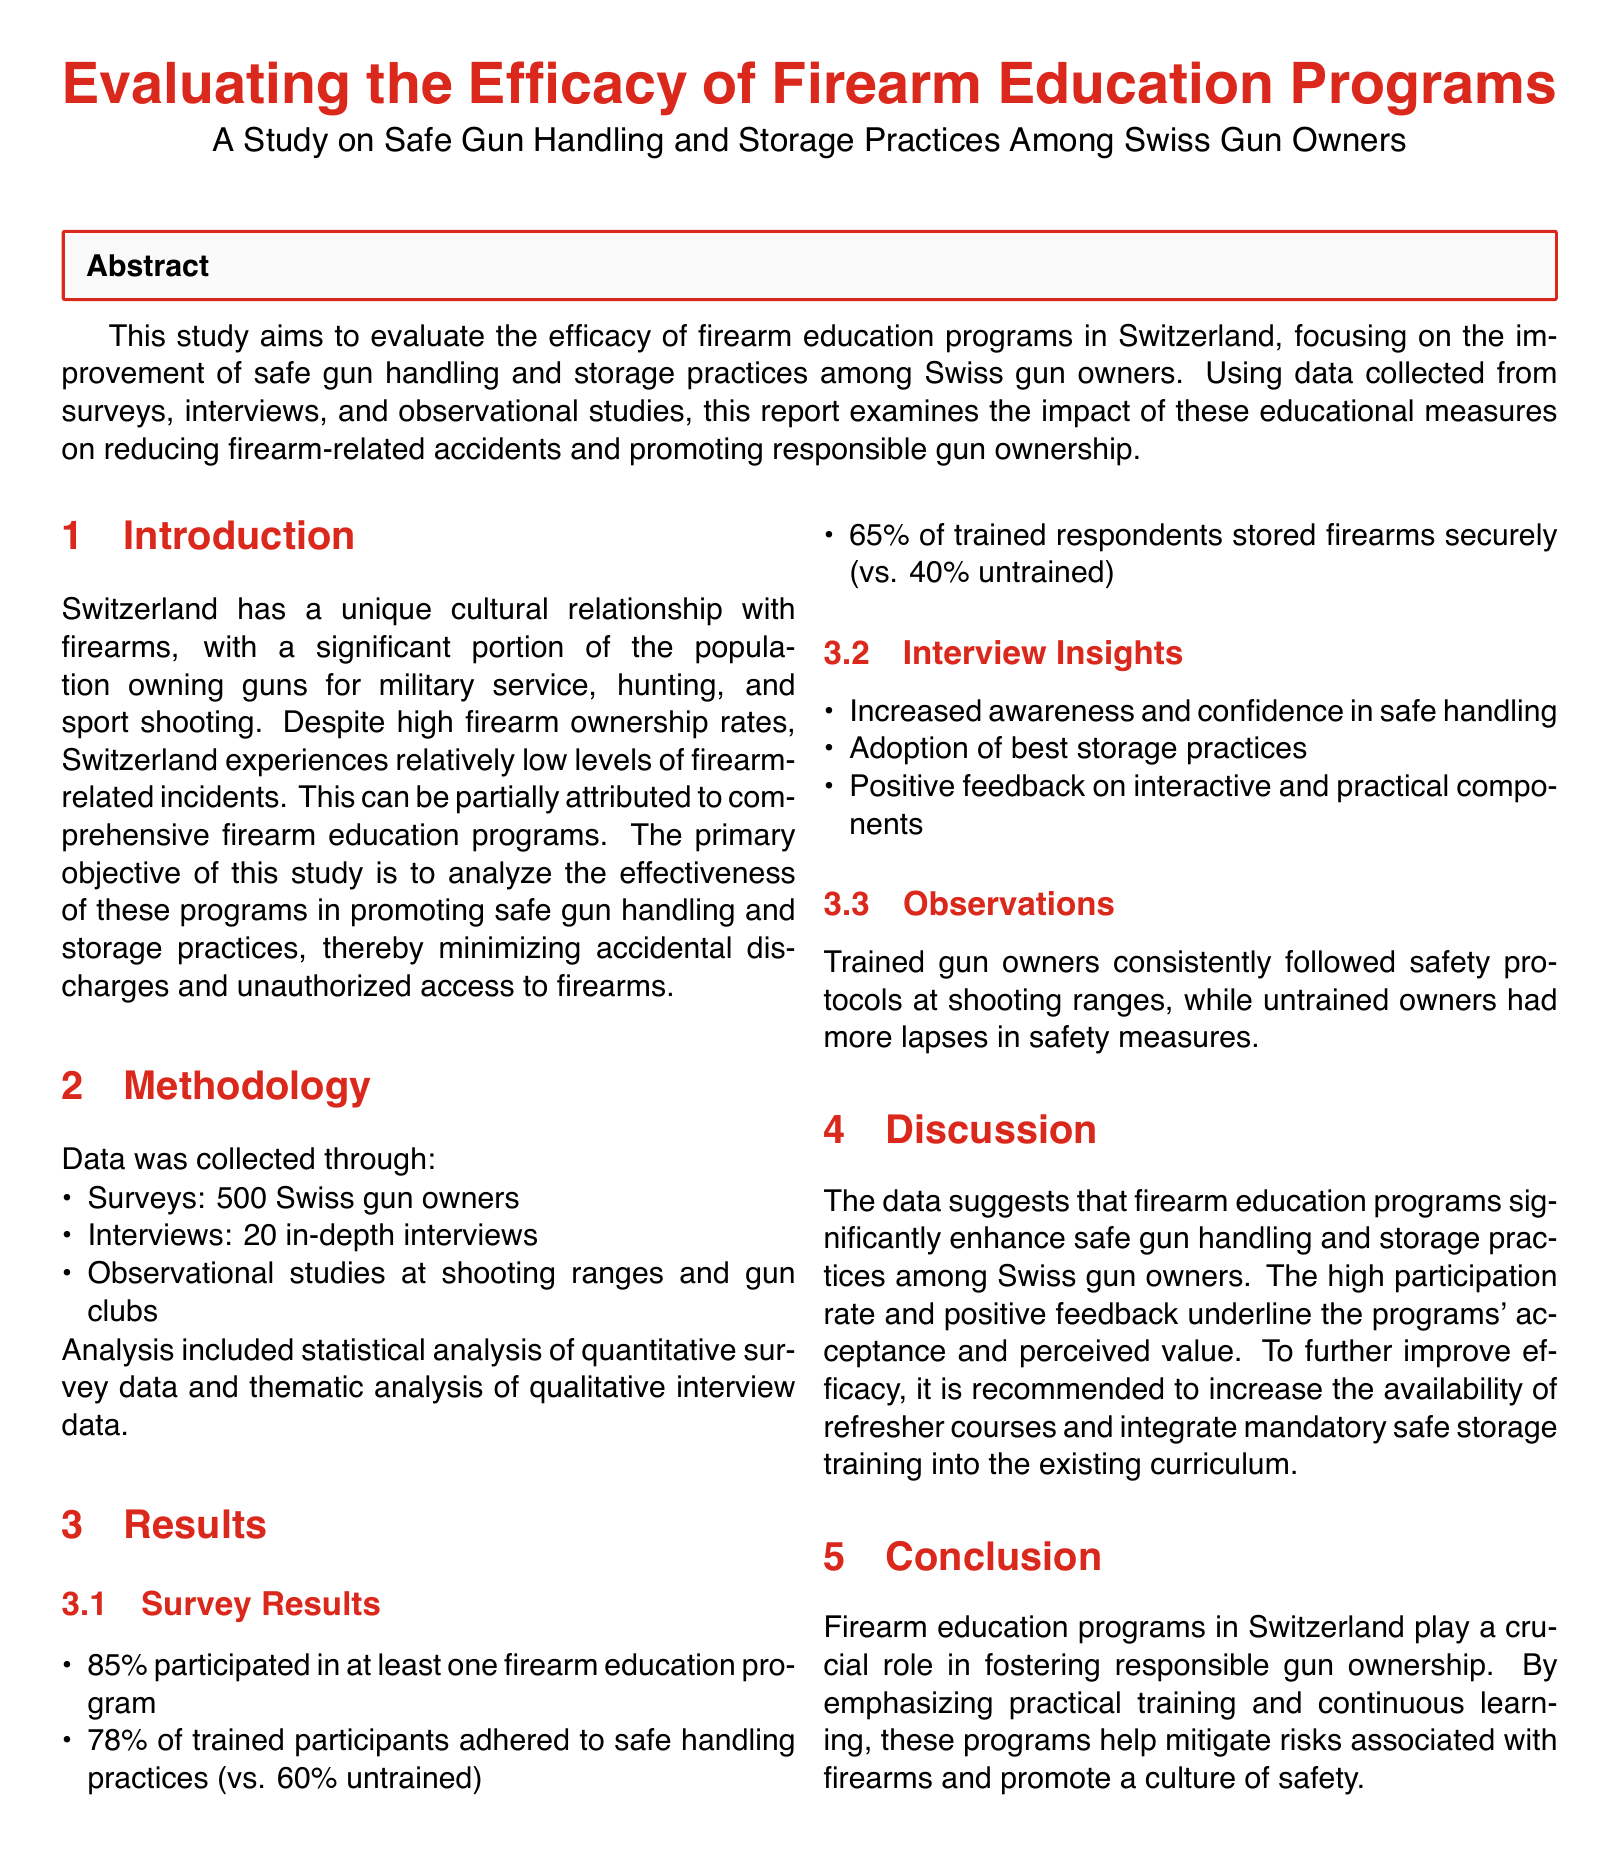What was the primary objective of the study? The primary objective of the study is to analyze the effectiveness of firearm education programs in promoting safe gun handling and storage practices.
Answer: Analyze the effectiveness of firearm education programs What percentage of trained participants adhered to safe handling practices? The document states that 78% of trained participants adhered to safe handling practices, while only 60% of untrained participants did.
Answer: 78% How many in-depth interviews were conducted? The report mentions that 20 in-depth interviews were conducted as part of the methodology.
Answer: 20 What was the percentage of gun owners who participated in at least one firearm education program? According to the survey results, 85% of gun owners participated in at least one firearm education program.
Answer: 85% What is a recommended improvement to the firearm education programs? The discussion section suggests increasing the availability of refresher courses as a recommended improvement.
Answer: Increase availability of refresher courses What type of analysis was used for qualitative data? The document states that thematic analysis was used for qualitative interview data.
Answer: Thematic analysis What did the observational studies reveal about trained gun owners? The observations indicated that trained gun owners consistently followed safety protocols at shooting ranges.
Answer: Consistently followed safety protocols What feedback did participants provide regarding the educational programs? The interview insights revealed that participants provided positive feedback on interactive and practical components of the programs.
Answer: Positive feedback on interactive and practical components What was one of the main cultural aspects surrounding firearms in Switzerland? The introduction highlights that a significant portion of the population owns guns for military service, hunting, and sport shooting.
Answer: Military service, hunting, and sport shooting 